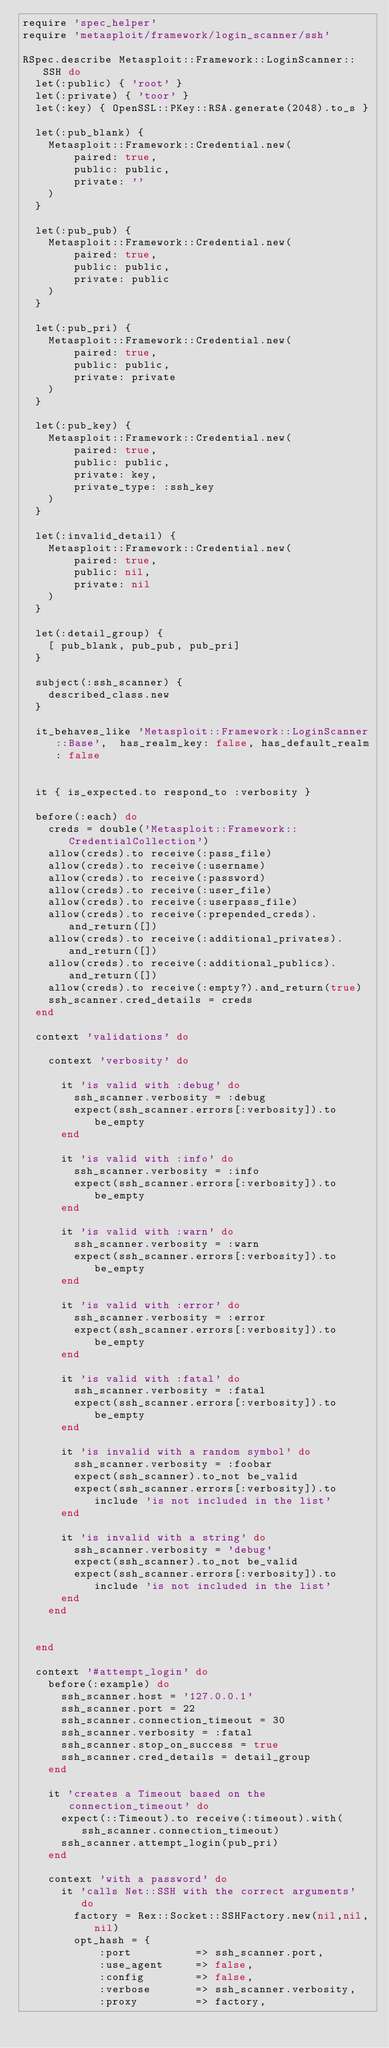Convert code to text. <code><loc_0><loc_0><loc_500><loc_500><_Ruby_>require 'spec_helper'
require 'metasploit/framework/login_scanner/ssh'

RSpec.describe Metasploit::Framework::LoginScanner::SSH do
  let(:public) { 'root' }
  let(:private) { 'toor' }
  let(:key) { OpenSSL::PKey::RSA.generate(2048).to_s }

  let(:pub_blank) {
    Metasploit::Framework::Credential.new(
        paired: true,
        public: public,
        private: ''
    )
  }

  let(:pub_pub) {
    Metasploit::Framework::Credential.new(
        paired: true,
        public: public,
        private: public
    )
  }

  let(:pub_pri) {
    Metasploit::Framework::Credential.new(
        paired: true,
        public: public,
        private: private
    )
  }

  let(:pub_key) {
    Metasploit::Framework::Credential.new(
        paired: true,
        public: public,
        private: key,
        private_type: :ssh_key
    )
  }

  let(:invalid_detail) {
    Metasploit::Framework::Credential.new(
        paired: true,
        public: nil,
        private: nil
    )
  }

  let(:detail_group) {
    [ pub_blank, pub_pub, pub_pri]
  }

  subject(:ssh_scanner) {
    described_class.new
  }

  it_behaves_like 'Metasploit::Framework::LoginScanner::Base',  has_realm_key: false, has_default_realm: false


  it { is_expected.to respond_to :verbosity }

  before(:each) do
    creds = double('Metasploit::Framework::CredentialCollection')
    allow(creds).to receive(:pass_file)
    allow(creds).to receive(:username)
    allow(creds).to receive(:password)
    allow(creds).to receive(:user_file)
    allow(creds).to receive(:userpass_file)
    allow(creds).to receive(:prepended_creds).and_return([])
    allow(creds).to receive(:additional_privates).and_return([])
    allow(creds).to receive(:additional_publics).and_return([])
    allow(creds).to receive(:empty?).and_return(true)
    ssh_scanner.cred_details = creds
  end

  context 'validations' do

    context 'verbosity' do

      it 'is valid with :debug' do
        ssh_scanner.verbosity = :debug
        expect(ssh_scanner.errors[:verbosity]).to be_empty
      end

      it 'is valid with :info' do
        ssh_scanner.verbosity = :info
        expect(ssh_scanner.errors[:verbosity]).to be_empty
      end

      it 'is valid with :warn' do
        ssh_scanner.verbosity = :warn
        expect(ssh_scanner.errors[:verbosity]).to be_empty
      end

      it 'is valid with :error' do
        ssh_scanner.verbosity = :error
        expect(ssh_scanner.errors[:verbosity]).to be_empty
      end

      it 'is valid with :fatal' do
        ssh_scanner.verbosity = :fatal
        expect(ssh_scanner.errors[:verbosity]).to be_empty
      end

      it 'is invalid with a random symbol' do
        ssh_scanner.verbosity = :foobar
        expect(ssh_scanner).to_not be_valid
        expect(ssh_scanner.errors[:verbosity]).to include 'is not included in the list'
      end

      it 'is invalid with a string' do
        ssh_scanner.verbosity = 'debug'
        expect(ssh_scanner).to_not be_valid
        expect(ssh_scanner.errors[:verbosity]).to include 'is not included in the list'
      end
    end


  end

  context '#attempt_login' do
    before(:example) do
      ssh_scanner.host = '127.0.0.1'
      ssh_scanner.port = 22
      ssh_scanner.connection_timeout = 30
      ssh_scanner.verbosity = :fatal
      ssh_scanner.stop_on_success = true
      ssh_scanner.cred_details = detail_group
    end

    it 'creates a Timeout based on the connection_timeout' do
      expect(::Timeout).to receive(:timeout).with(ssh_scanner.connection_timeout)
      ssh_scanner.attempt_login(pub_pri)
    end

    context 'with a password' do
      it 'calls Net::SSH with the correct arguments' do
        factory = Rex::Socket::SSHFactory.new(nil,nil,nil)
        opt_hash = {
            :port          => ssh_scanner.port,
            :use_agent     => false,
            :config        => false,
            :verbose       => ssh_scanner.verbosity,
            :proxy         => factory,</code> 